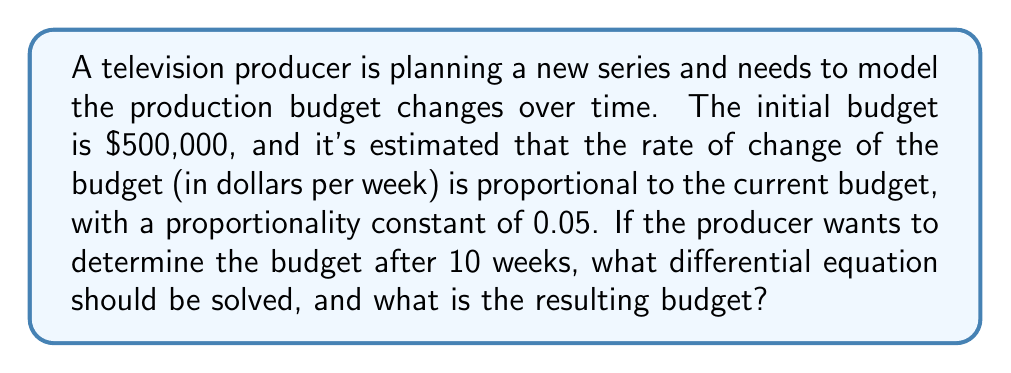Show me your answer to this math problem. To solve this problem, we need to use a first-order differential equation. Let's break it down step by step:

1. Define variables:
   Let $B(t)$ be the budget in dollars at time $t$ in weeks.

2. Set up the differential equation:
   The rate of change of the budget is proportional to the current budget:
   $$\frac{dB}{dt} = 0.05B$$

3. This is a separable differential equation. We can solve it as follows:
   $$\frac{dB}{B} = 0.05dt$$

4. Integrate both sides:
   $$\int \frac{dB}{B} = \int 0.05dt$$
   $$\ln|B| = 0.05t + C$$

5. Take the exponential of both sides:
   $$B = e^{0.05t + C} = e^C \cdot e^{0.05t}$$

6. Use the initial condition: At $t=0$, $B(0) = 500,000$
   $$500,000 = e^C \cdot e^0 = e^C$$
   $$e^C = 500,000$$

7. Substitute this back into our general solution:
   $$B(t) = 500,000 \cdot e^{0.05t}$$

8. To find the budget after 10 weeks, substitute $t=10$:
   $$B(10) = 500,000 \cdot e^{0.05 \cdot 10}$$
   $$B(10) = 500,000 \cdot e^{0.5}$$
   $$B(10) = 500,000 \cdot 1.6487$$
   $$B(10) = 824,350$$ (rounded to the nearest dollar)
Answer: The differential equation to be solved is $\frac{dB}{dt} = 0.05B$, and the resulting budget after 10 weeks is $824,350. 